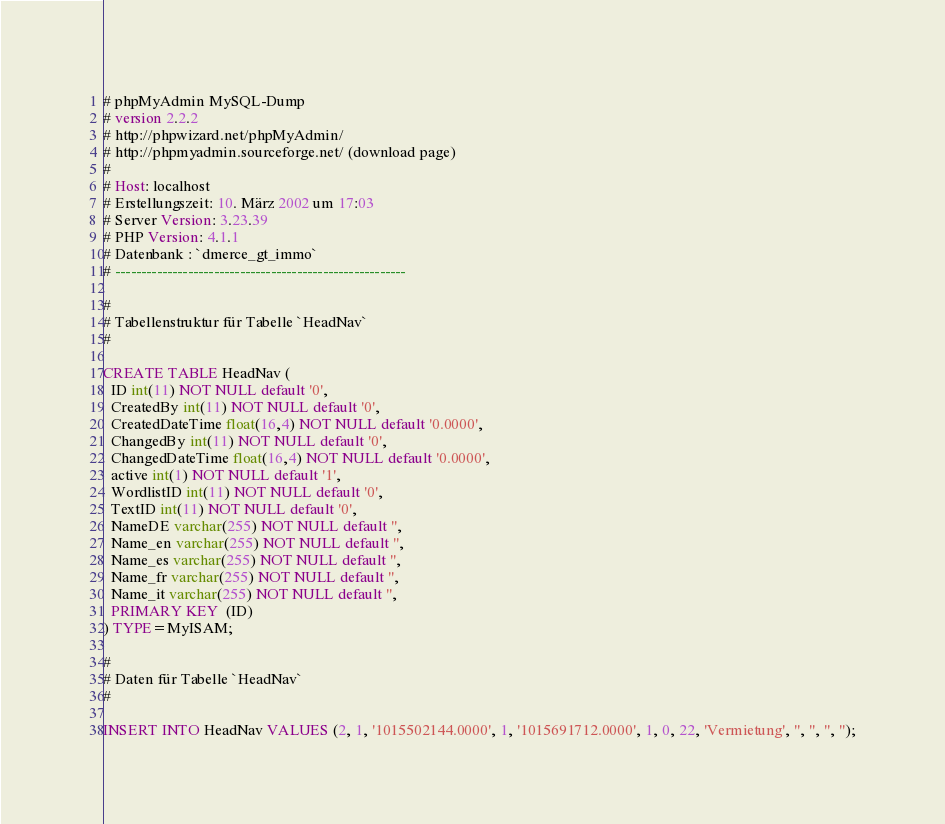Convert code to text. <code><loc_0><loc_0><loc_500><loc_500><_SQL_># phpMyAdmin MySQL-Dump
# version 2.2.2
# http://phpwizard.net/phpMyAdmin/
# http://phpmyadmin.sourceforge.net/ (download page)
#
# Host: localhost
# Erstellungszeit: 10. März 2002 um 17:03
# Server Version: 3.23.39
# PHP Version: 4.1.1
# Datenbank : `dmerce_gt_immo`
# --------------------------------------------------------

#
# Tabellenstruktur für Tabelle `HeadNav`
#

CREATE TABLE HeadNav (
  ID int(11) NOT NULL default '0',
  CreatedBy int(11) NOT NULL default '0',
  CreatedDateTime float(16,4) NOT NULL default '0.0000',
  ChangedBy int(11) NOT NULL default '0',
  ChangedDateTime float(16,4) NOT NULL default '0.0000',
  active int(1) NOT NULL default '1',
  WordlistID int(11) NOT NULL default '0',
  TextID int(11) NOT NULL default '0',
  NameDE varchar(255) NOT NULL default '',
  Name_en varchar(255) NOT NULL default '',
  Name_es varchar(255) NOT NULL default '',
  Name_fr varchar(255) NOT NULL default '',
  Name_it varchar(255) NOT NULL default '',
  PRIMARY KEY  (ID)
) TYPE=MyISAM;

#
# Daten für Tabelle `HeadNav`
#

INSERT INTO HeadNav VALUES (2, 1, '1015502144.0000', 1, '1015691712.0000', 1, 0, 22, 'Vermietung', '', '', '', '');

</code> 